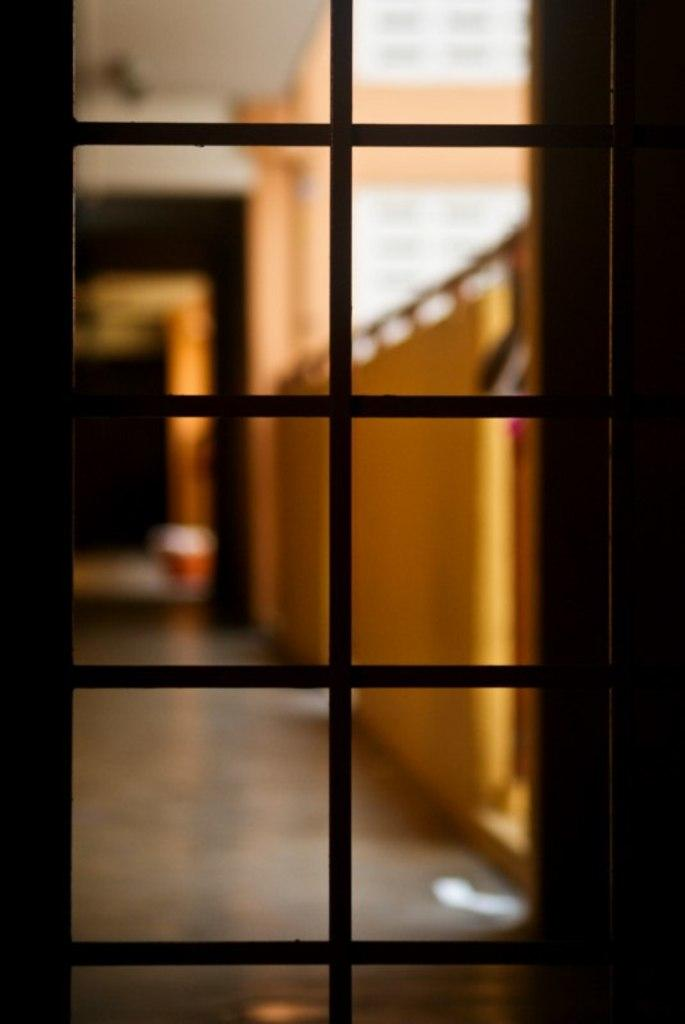What type of view is shown in the image? The image is an inside view. What can be seen through the glass door in the image? The floor and walls are visible behind the door. How is the background of the image depicted? The background is blurred. How many eggs are visible on the floor in the image? There are no eggs visible on the floor in the image. What sense is being used to perceive the image? The image is being perceived visually, using the sense of sight. 